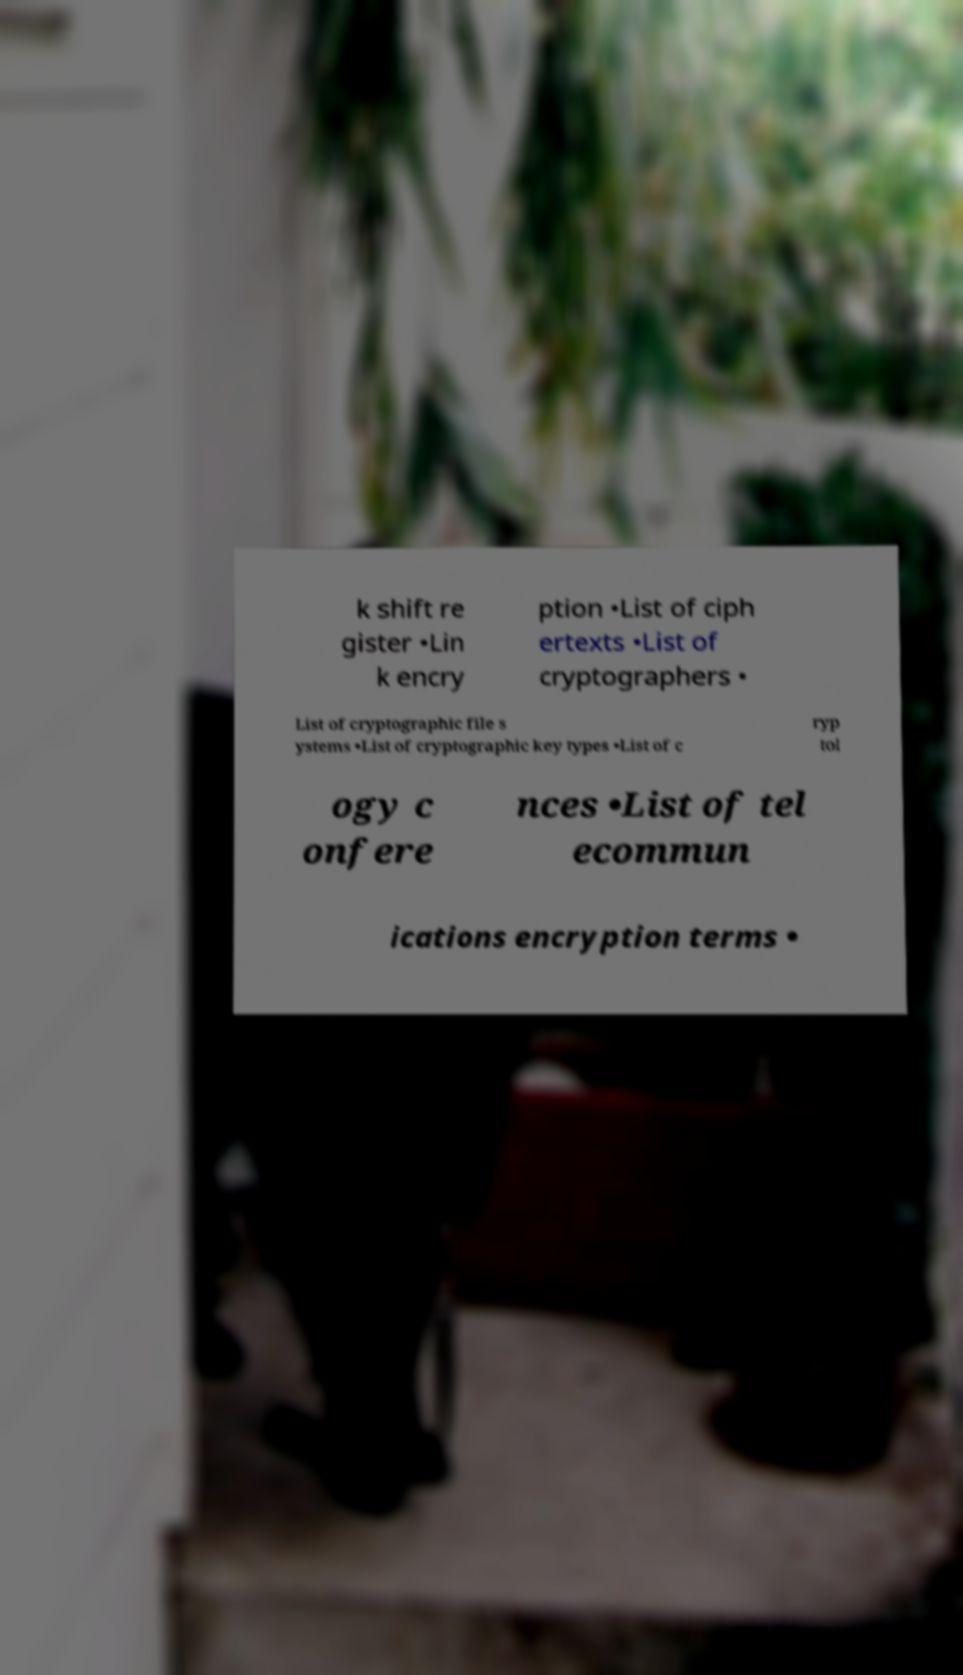Can you accurately transcribe the text from the provided image for me? k shift re gister •Lin k encry ption •List of ciph ertexts •List of cryptographers • List of cryptographic file s ystems •List of cryptographic key types •List of c ryp tol ogy c onfere nces •List of tel ecommun ications encryption terms • 